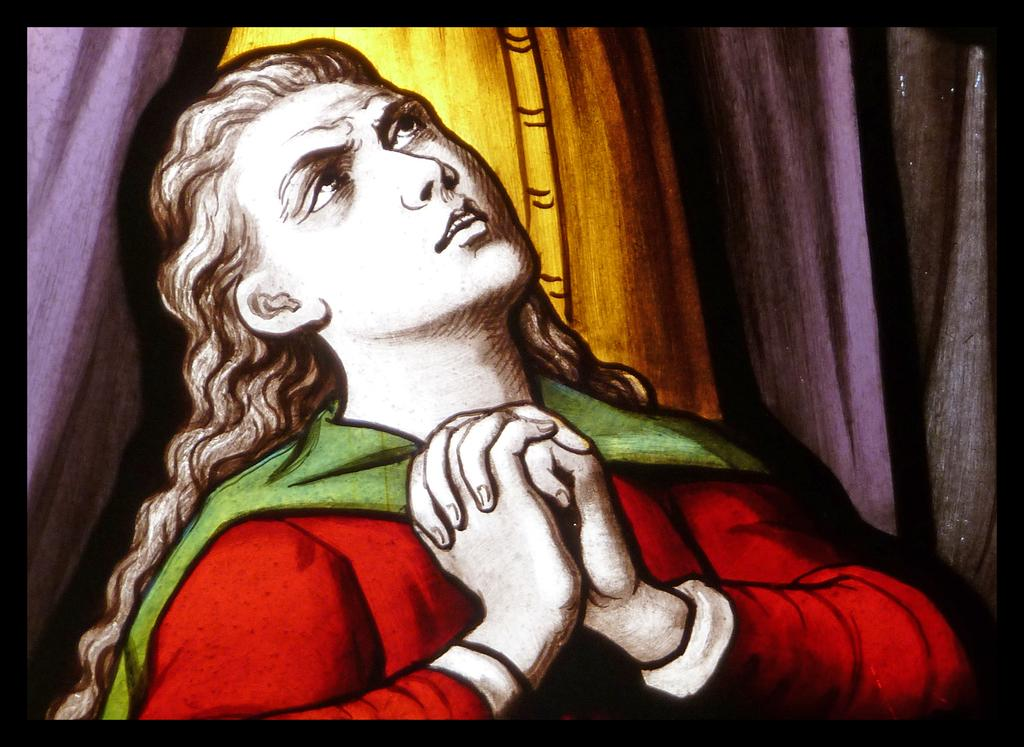What is the main subject of the image? There is a depiction of a person in the image. How many tomatoes are on the person's head in the image? There are no tomatoes present in the image; it only depicts a person. Is there a bee buzzing around the person in the image? There is no bee visible in the image; it only depicts a person. 